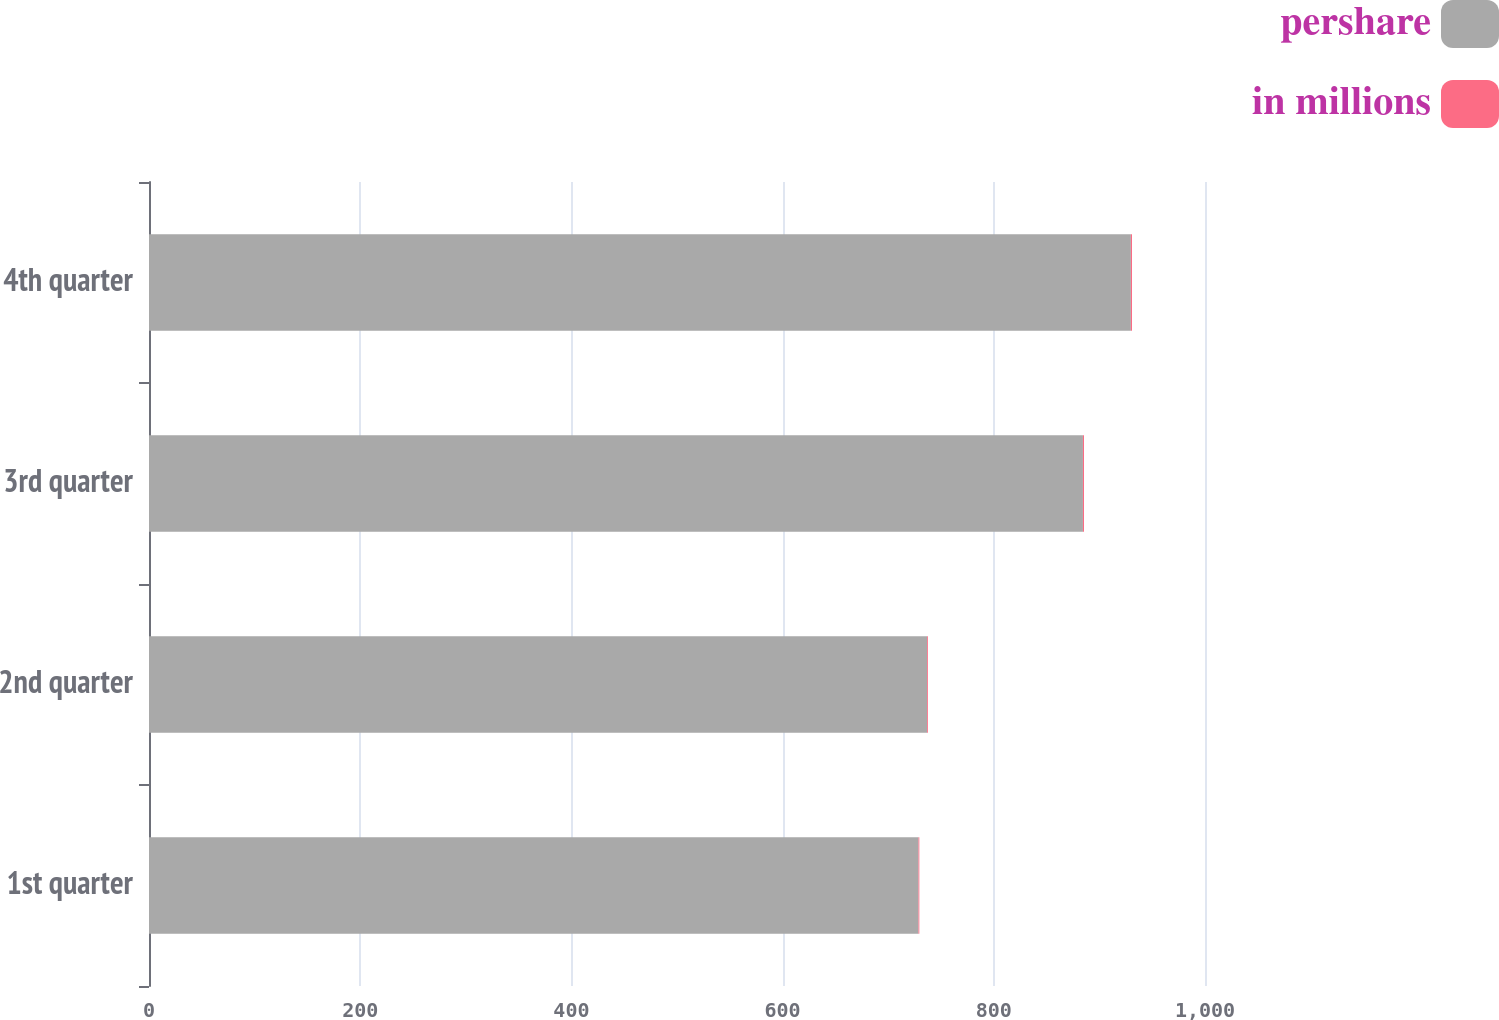<chart> <loc_0><loc_0><loc_500><loc_500><stacked_bar_chart><ecel><fcel>1st quarter<fcel>2nd quarter<fcel>3rd quarter<fcel>4th quarter<nl><fcel>pershare<fcel>728.7<fcel>736.8<fcel>884.4<fcel>929.8<nl><fcel>in millions<fcel>0.78<fcel>0.81<fcel>1.03<fcel>1.1<nl></chart> 